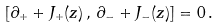Convert formula to latex. <formula><loc_0><loc_0><loc_500><loc_500>[ \partial _ { + } + J _ { + } ( z ) \, , \, \partial _ { - } + J _ { - } ( z ) ] = 0 \, .</formula> 